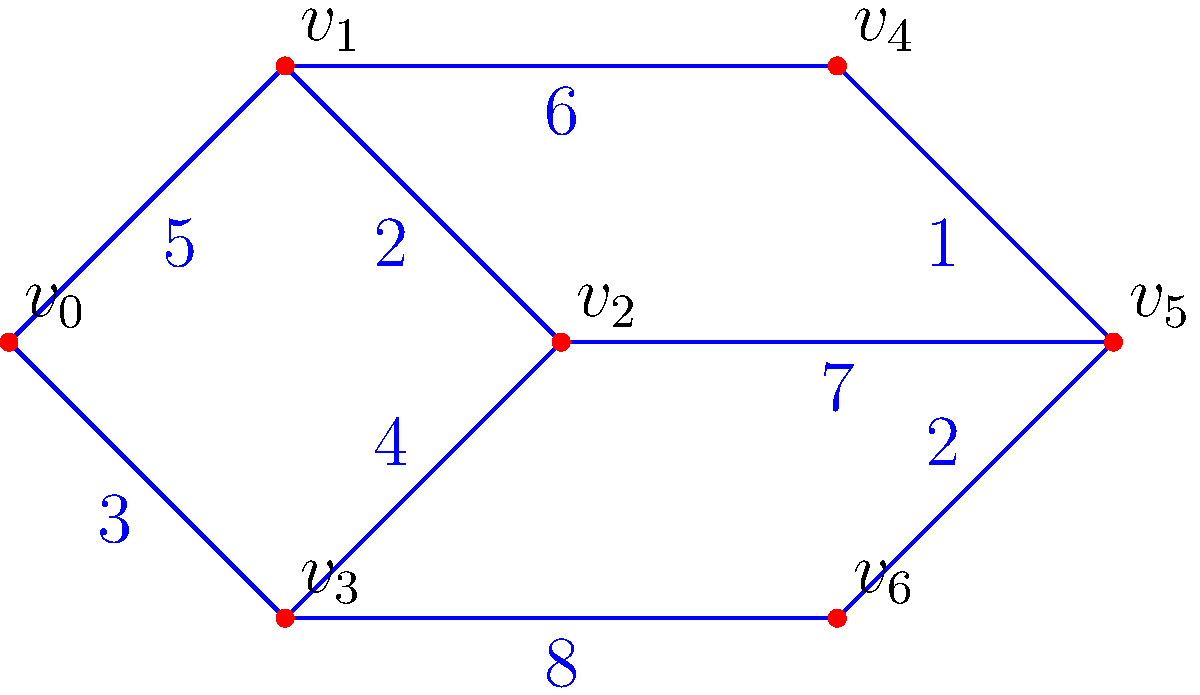As an Internet promotional planner, you're optimizing a content delivery network (CDN) for your startup's new marketing campaign. The network is represented by the weighted graph above, where vertices are servers and edge weights represent transmission times in milliseconds. What is the minimum total transmission time required to send promotional content from server $v_0$ to server $v_6$? To find the minimum total transmission time, we need to find the shortest path from $v_0$ to $v_6$. We can use Dijkstra's algorithm to solve this problem:

1. Initialize distances: $d(v_0) = 0$, all others $\infty$
2. Set $S = \{\}$ (visited vertices) and $Q = \{v_0, v_1, v_2, v_3, v_4, v_5, v_6\}$

3. While $Q$ is not empty:
   a. Select vertex $u$ in $Q$ with minimum $d(u)$
   b. Remove $u$ from $Q$ and add to $S$
   c. For each neighbor $v$ of $u$:
      If $d(v) > d(u) + w(u,v)$, update $d(v) = d(u) + w(u,v)$

4. Iteration 1: Select $v_0$
   Update: $d(v_1) = 5$, $d(v_3) = 3$

5. Iteration 2: Select $v_3$
   Update: $d(v_2) = 7$, $d(v_6) = 11$

6. Iteration 3: Select $v_1$
   Update: $d(v_2) = \min(7, 5+2) = 7$, $d(v_4) = 11$

7. Iteration 4: Select $v_2$
   Update: $d(v_5) = 14$

8. Iteration 5: Select $v_4$
   Update: $d(v_5) = \min(14, 11+1) = 12$

9. Iteration 6: Select $v_5$
   Update: $d(v_6) = \min(11, 12+2) = 11$

10. Iteration 7: Select $v_6$
    Algorithm terminates

The shortest path is $v_0 \rightarrow v_3 \rightarrow v_6$ with a total transmission time of 11 milliseconds.
Answer: 11 milliseconds 